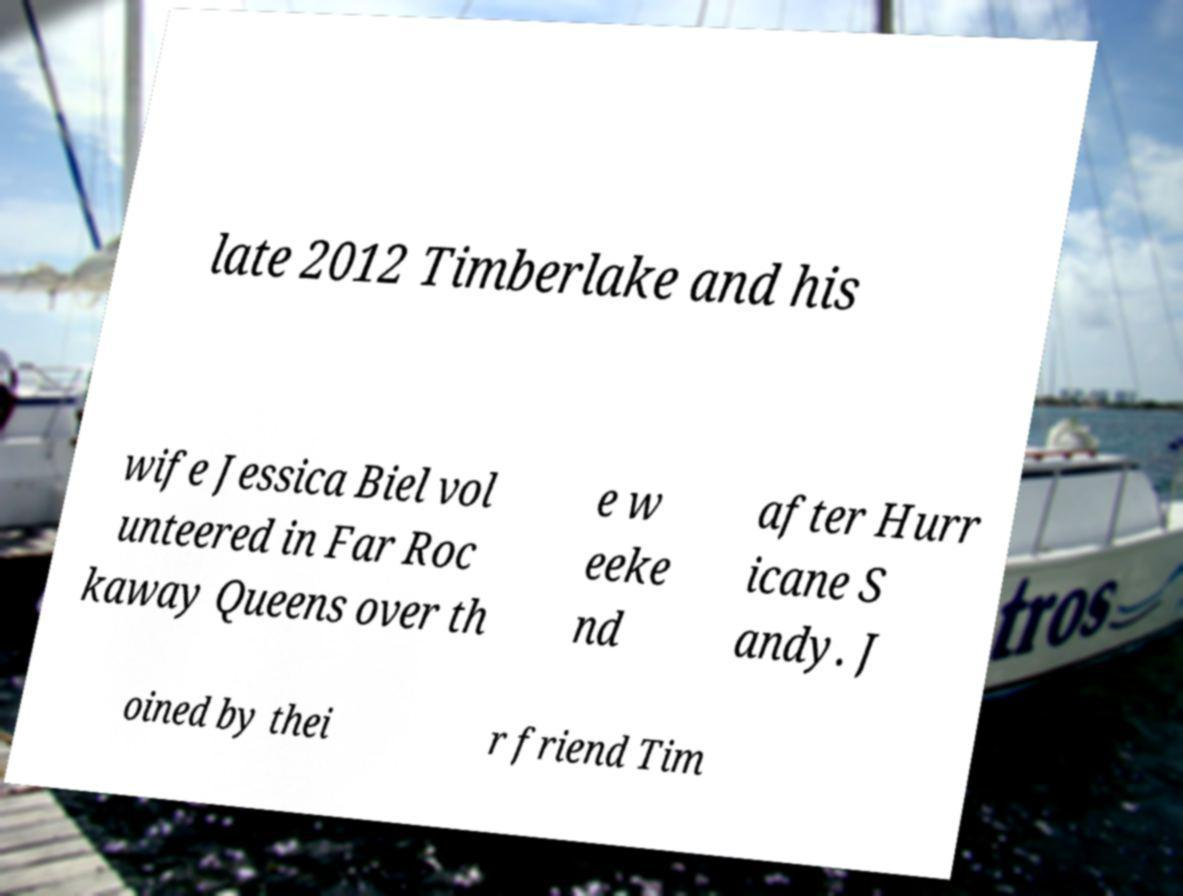What messages or text are displayed in this image? I need them in a readable, typed format. late 2012 Timberlake and his wife Jessica Biel vol unteered in Far Roc kaway Queens over th e w eeke nd after Hurr icane S andy. J oined by thei r friend Tim 